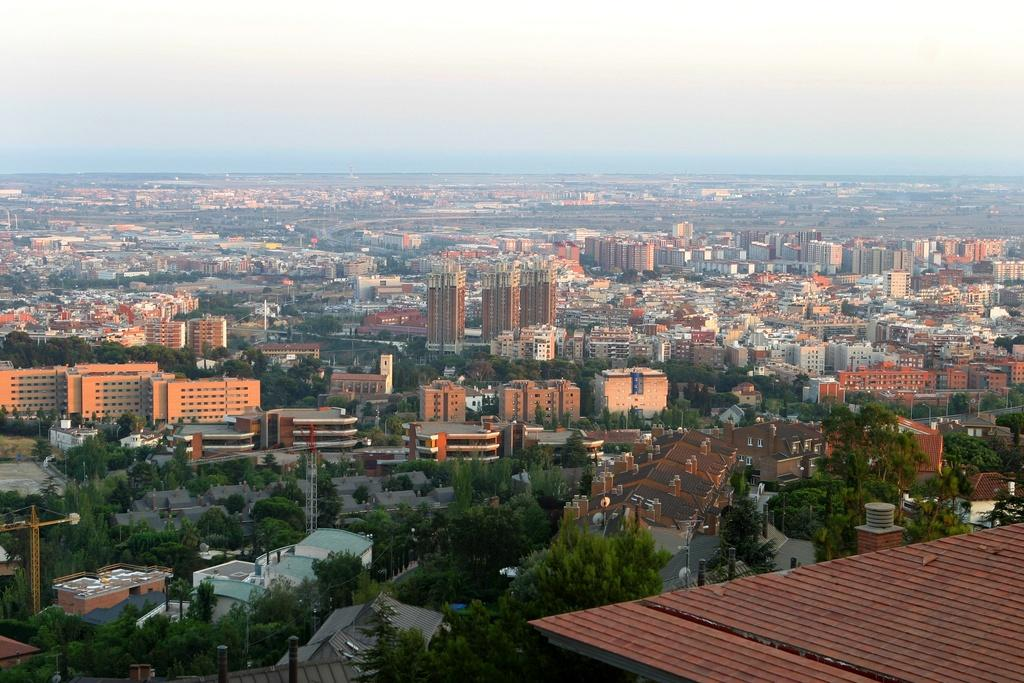Where was the picture taken? The picture was clicked outside. What can be seen in the foreground of the image? There are trees and buildings in the foreground of the image, along with metal rods. What is visible in the background of the image? The sky is visible in the background of the image, along with buildings and other objects. How many hearts can be seen in the image? There are no hearts visible in the image. What shape do the bushes in the image form? There are no bushes present in the image. 